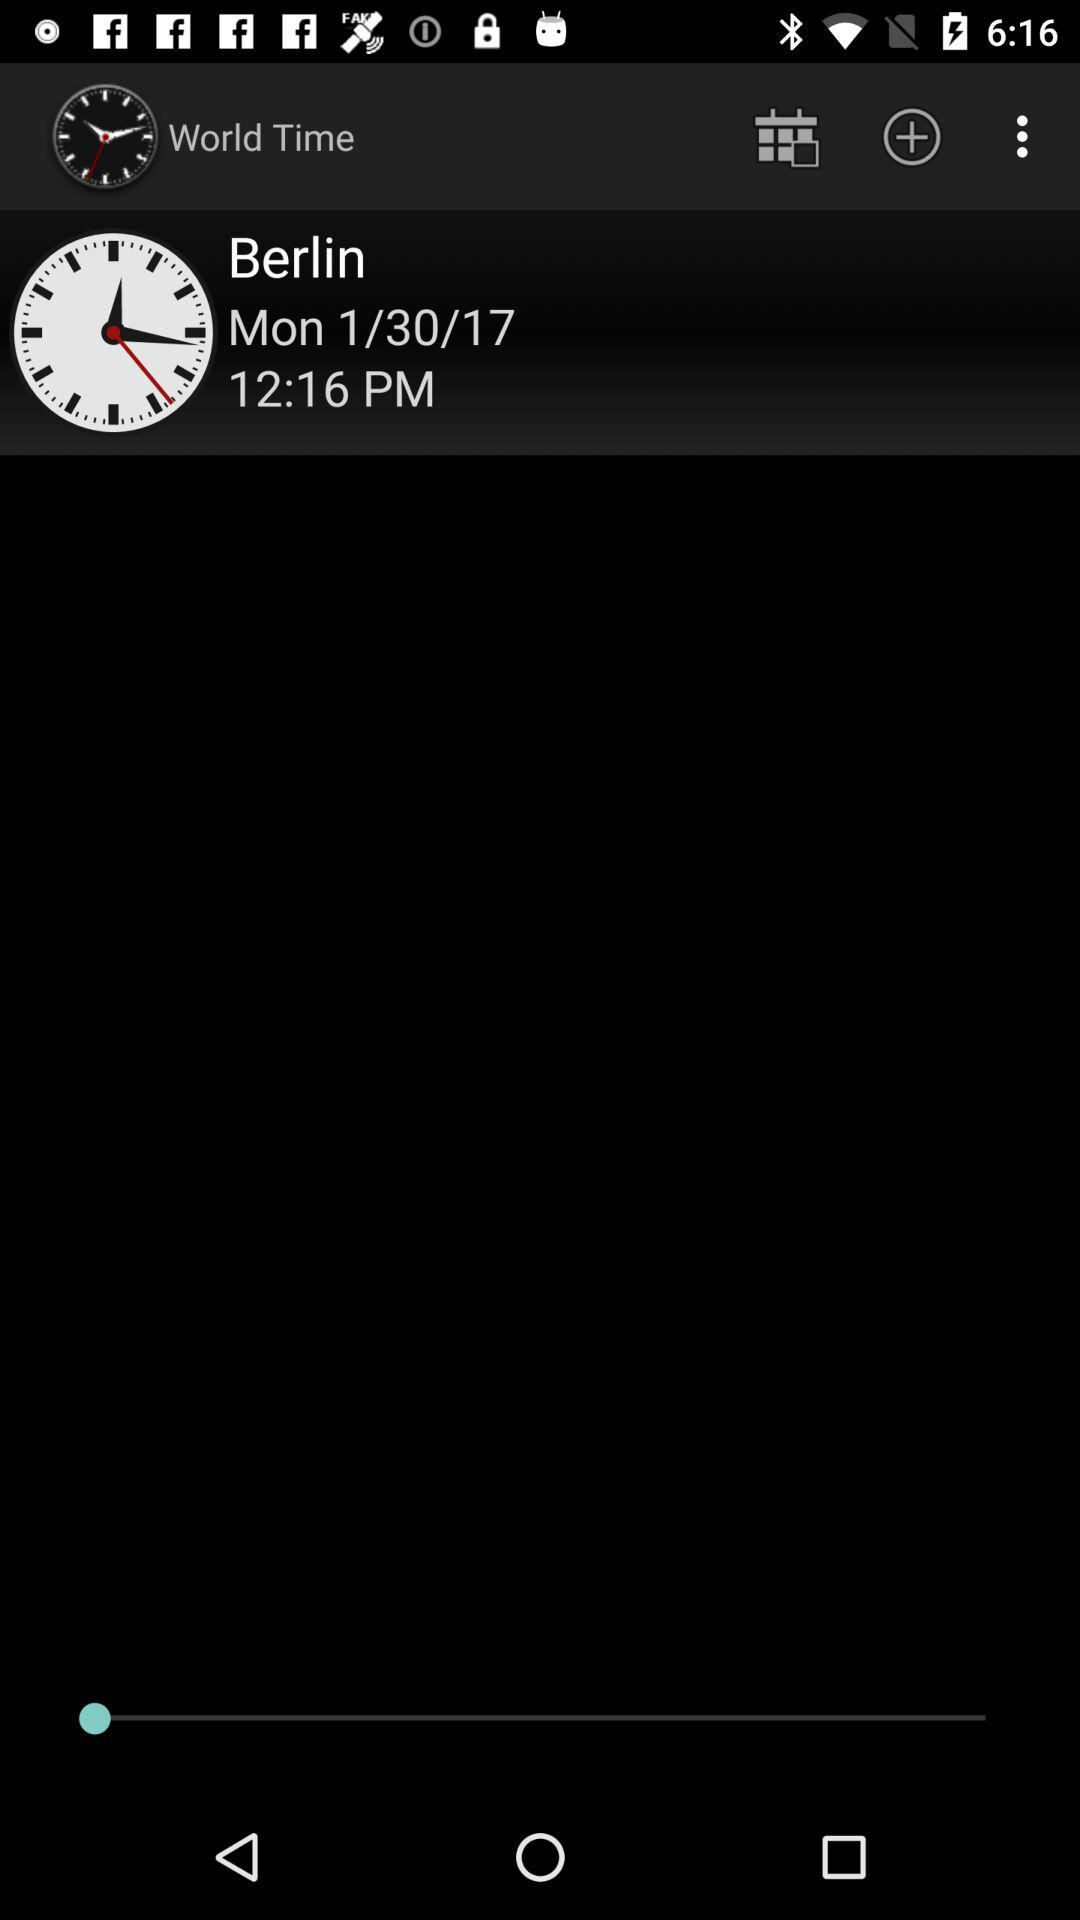Which place's time and date are shown? The time and date are shown for Berlin. 